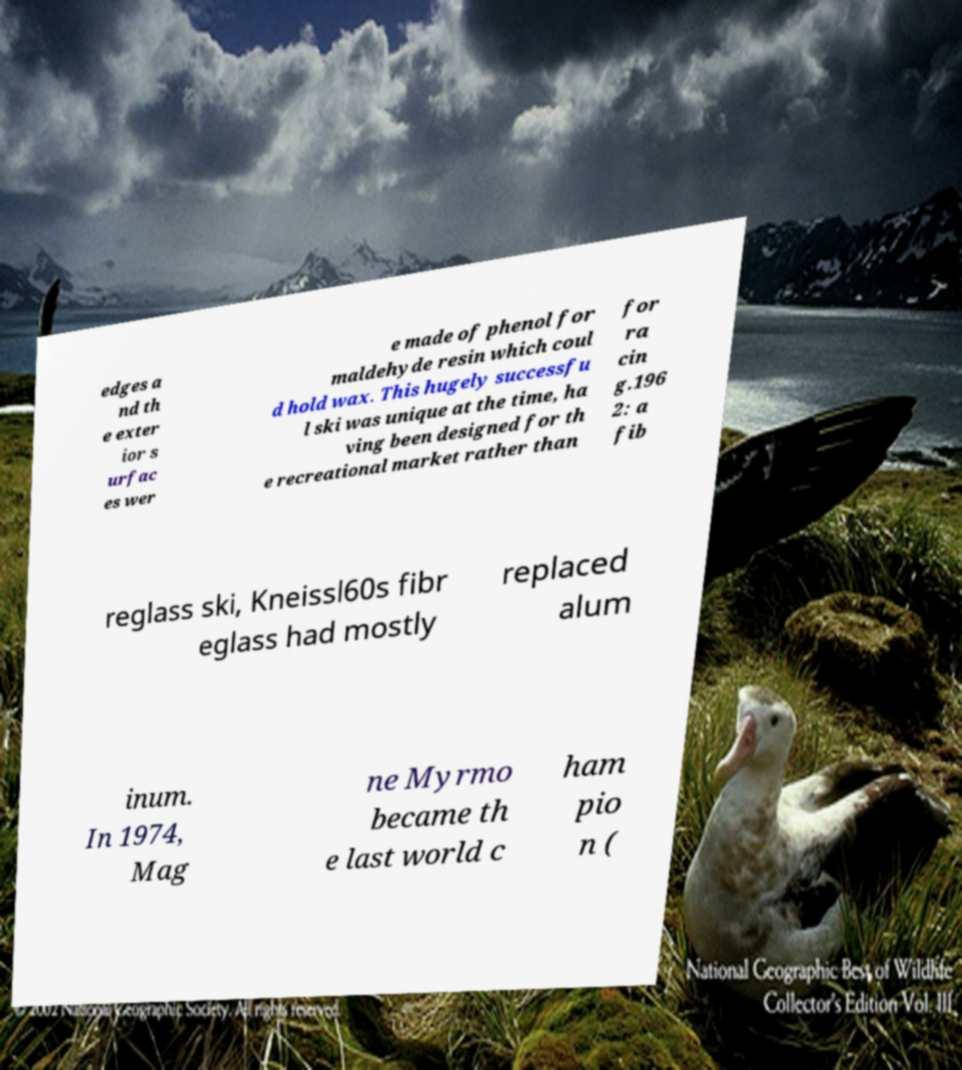Please identify and transcribe the text found in this image. edges a nd th e exter ior s urfac es wer e made of phenol for maldehyde resin which coul d hold wax. This hugely successfu l ski was unique at the time, ha ving been designed for th e recreational market rather than for ra cin g.196 2: a fib reglass ski, Kneissl60s fibr eglass had mostly replaced alum inum. In 1974, Mag ne Myrmo became th e last world c ham pio n ( 